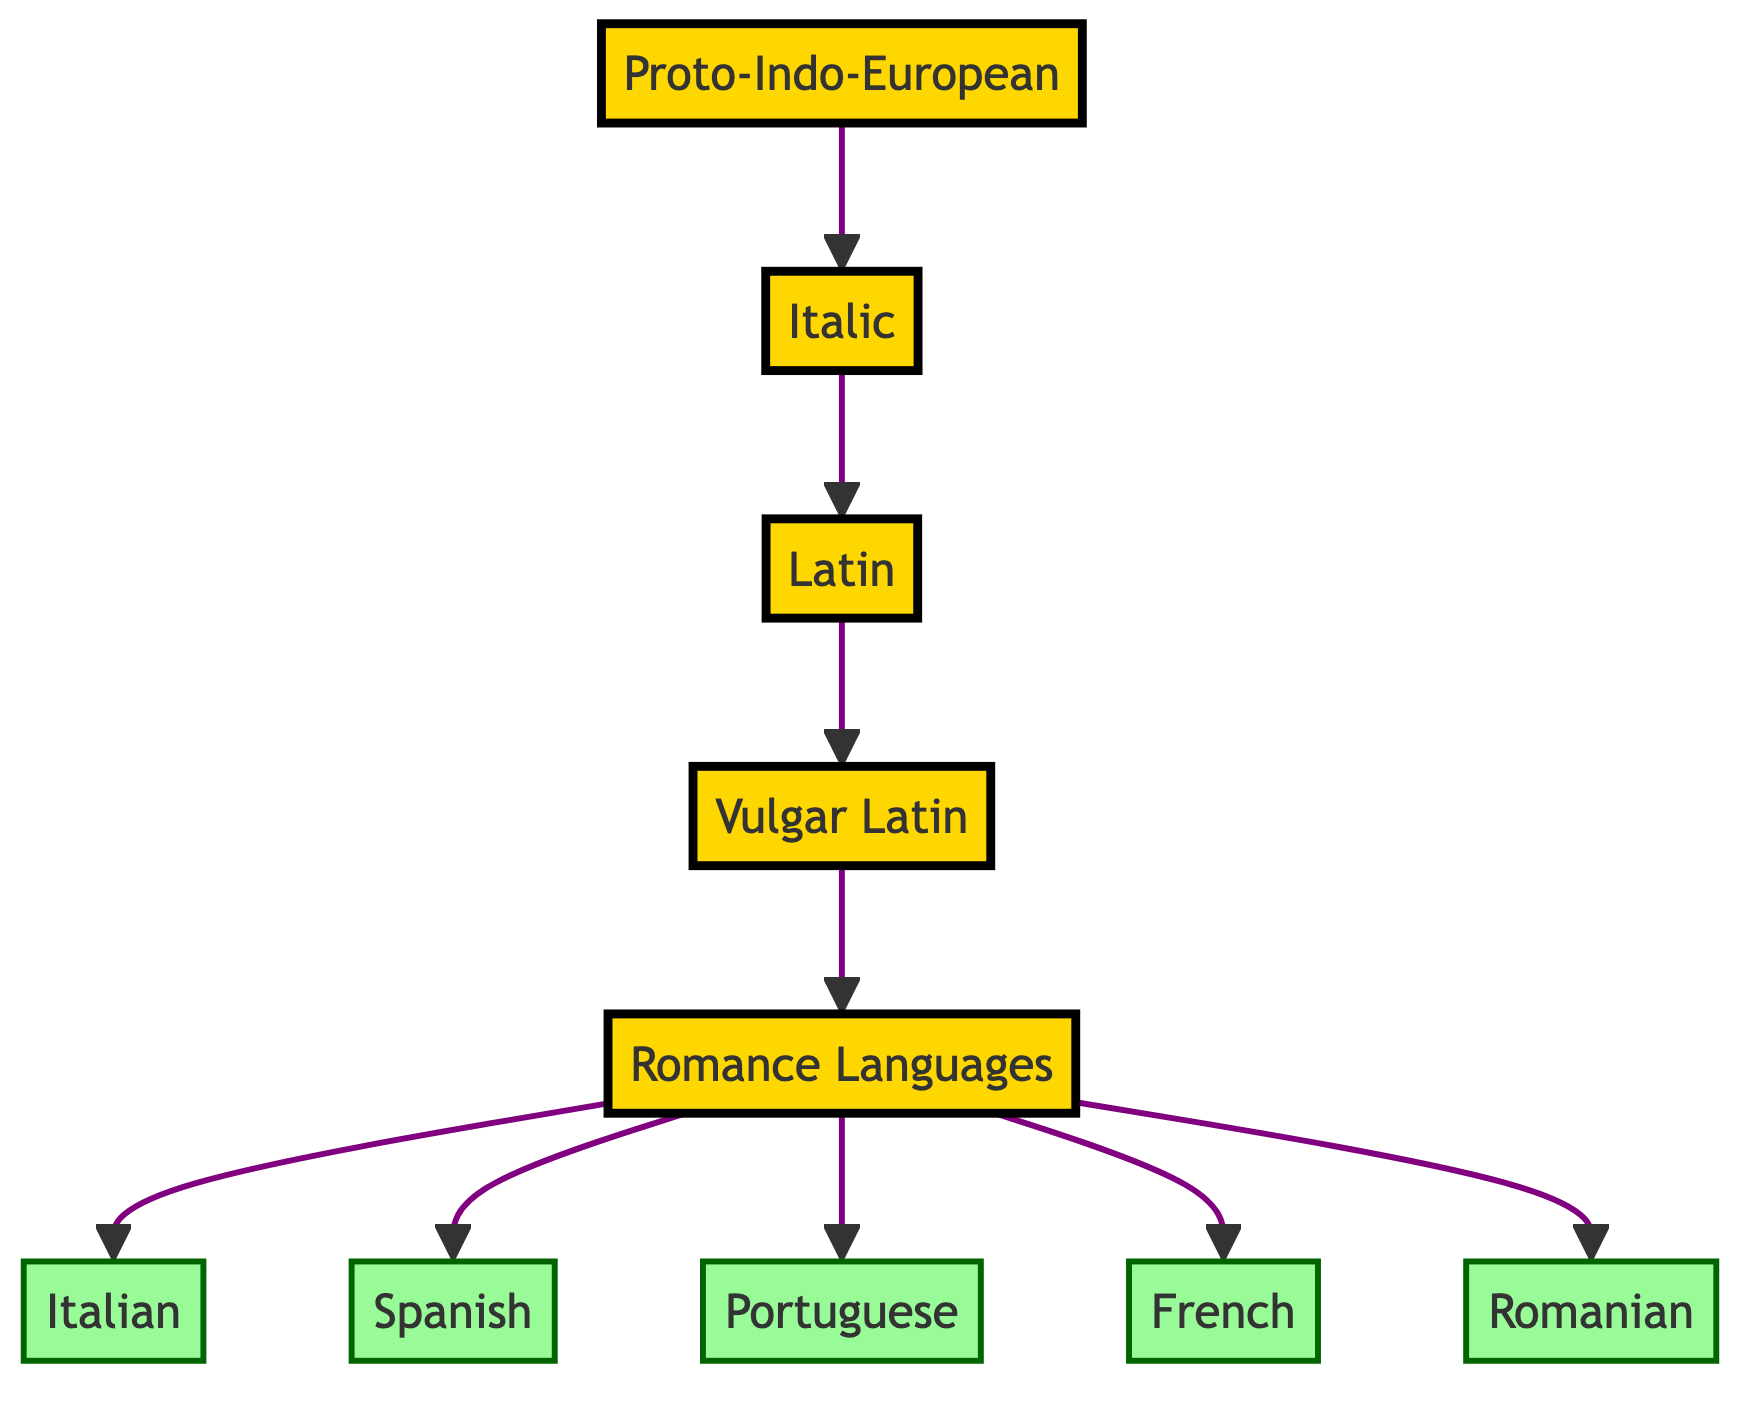What is the top node of the family tree? The top node represents the earliest ancestor in the tree, which is Proto-Indo-European, indicated at the highest level of the diagram.
Answer: Proto-Indo-European How many modern languages are shown as descendants of the Romance Languages? Counting the leaves at the bottom of the tree, there are five distinct modern languages branching from Romance Languages.
Answer: 5 What is the immediate descendant of Latin? Looking directly below Latin, the next level down shows Vulgar Latin as its immediate descendant.
Answer: Vulgar Latin Which branch comes directly from Proto-Indo-European? The first branch extending from Proto-Indo-European in the diagram is Italic, showing a direct line of descent to Latin and its derivatives.
Answer: Italic What classification is assigned to Vulgar Latin in the diagram? Vulgar Latin is visually designated with the ancient classification, indicating its historical significance and origins in the ancient language lineage.
Answer: ancient Which language is not a direct descendant of Latin? By analyzing the flow of the diagram from Proto-Indo-European to its descendants, we see that all languages listed after Vulgar Latin are descendants, confirming that there are no non-descendants shown.
Answer: None How many layers are there in total from Proto-Indo-European to the modern languages? The diagram contains five distinct layers: Proto-Indo-European, Italic, Latin, Vulgar Latin, and finally Romance Languages leading to the five modern languages.
Answer: 5 What is the relationship between Vulgar Latin and Romance Languages? The relationship indicates that Vulgar Latin serves as the parent or predecessor to the Romance Languages, showing a direct lineage from one to the other.
Answer: Parent What color represents the modern languages in the diagram? The modern languages, which branch from Romance Languages, are colored in light green, distinguishing them from the ancient languages colored in gold.
Answer: light green 